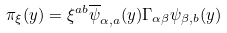<formula> <loc_0><loc_0><loc_500><loc_500>\pi _ { \xi } ( y ) = \xi ^ { a b } \overline { \psi } _ { \alpha , a } ( y ) \Gamma _ { \alpha \beta } \psi _ { \beta , b } ( y )</formula> 